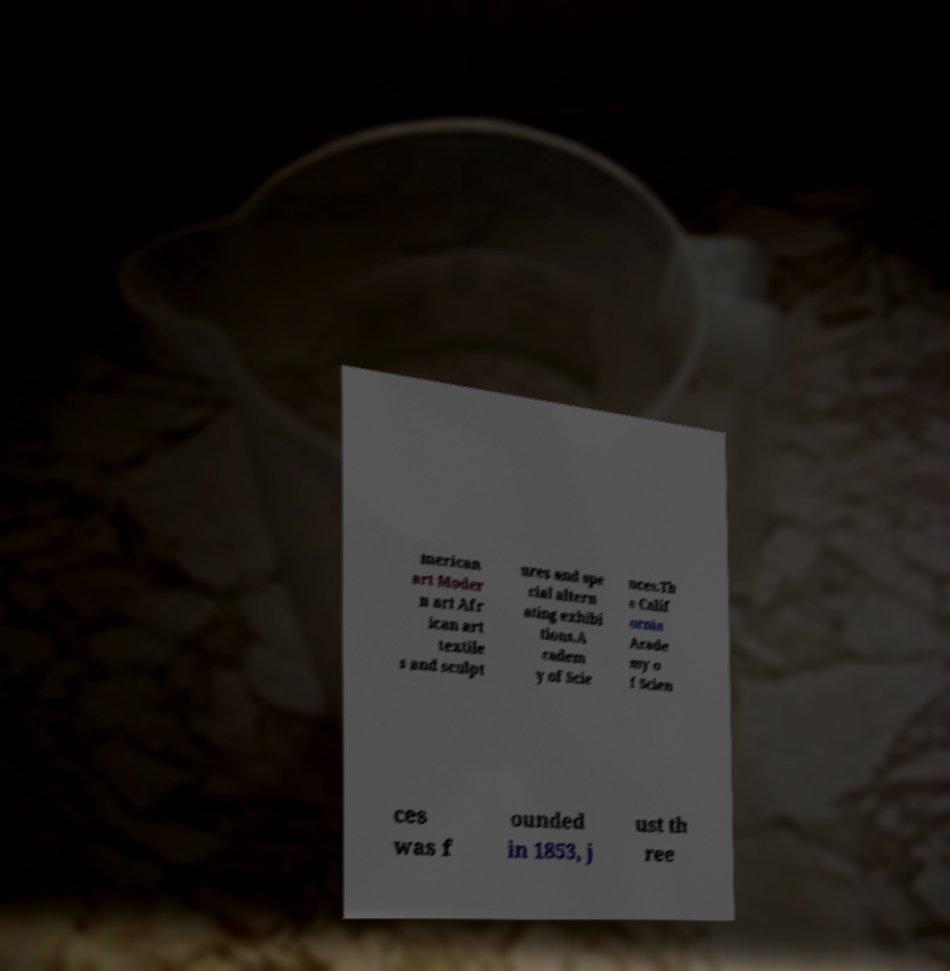What messages or text are displayed in this image? I need them in a readable, typed format. merican art Moder n art Afr ican art textile s and sculpt ures and spe cial altern ating exhibi tions.A cadem y of Scie nces.Th e Calif ornia Acade my o f Scien ces was f ounded in 1853, j ust th ree 